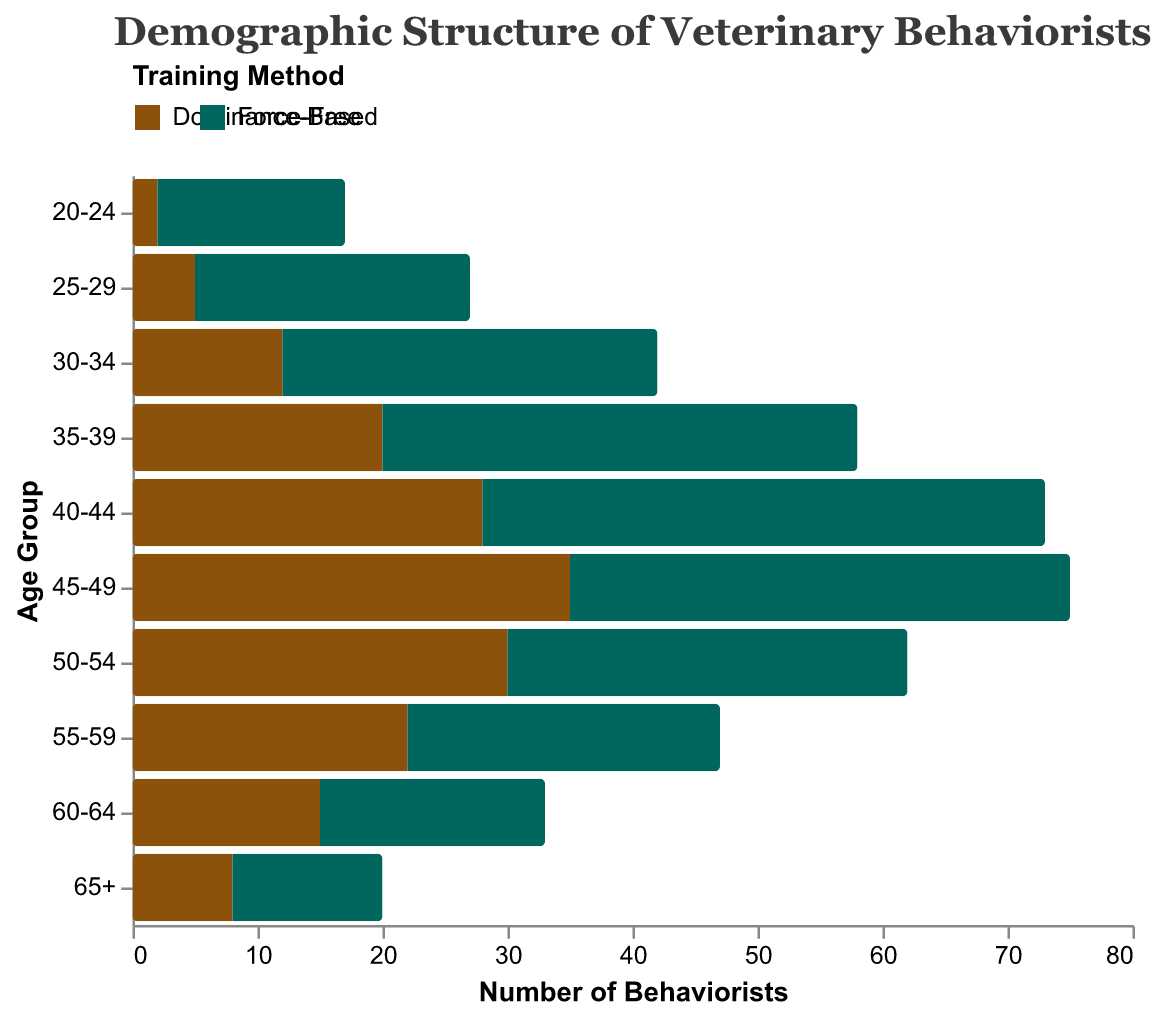What's the title of the figure? The title is displayed at the top of the figure, indicating the subject of the graph. In this case, it reads "Demographic Structure of Veterinary Behaviorists."
Answer: Demographic Structure of Veterinary Behaviorists What are the two training methods represented in the figure? The legend at the top shows two training methods with distinct colors: Dominance-Based and Force-Free.
Answer: Dominance-Based and Force-Free Which age group has the highest number of dominance-based behaviorists? By examining the bars representing Dominance-Based behaviorists, the age group 45-49 has the longest bar, indicating the highest number.
Answer: 45-49 Which age group has the greatest discrepancy between Dominance-Based and Force-Free behaviorists? Visual inspection of the lengths of bars for each age group reveals the greatest discrepancy at age group 40-44. The difference between 28 (Dominance-Based) and -45 (Force-Free) is 28 + 45 = 73.
Answer: 40-44 Which training method has more behaviorists in the age group 55-59? Observe the respective bars. Dominance-Based has a value of 22, and Force-Free has a value of -25. Since 25 > 22, Force-Free has more behaviorists.
Answer: Force-Free What's the combined number of Dominance-Based behaviorists in the age groups 30-34 and 35-39? Add the values for Dominance-Based behaviorists in these age groups: 12 (30-34) + 20 (35-39) = 32.
Answer: 32 Which age group has the smallest number of force-free behaviorists? The smallest negative value in the Force-Free category bar indicates the smallest number, which is age group 20-24 with -15.
Answer: 20-24 How does the number of Dominance-Based behaviorists in the 45-49 age group compare to the Force-Free behaviorists in the same group? Dominance-Based behaviorists are 35, while Force-Free behaviorists are -40. Thus, 35 Dominance-Based is less than 40 Force-Free.
Answer: Less 